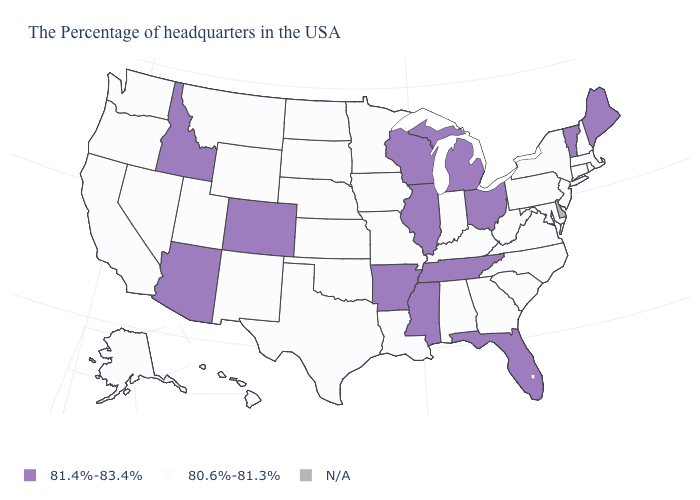What is the value of Arkansas?
Short answer required. 81.4%-83.4%. What is the value of Iowa?
Quick response, please. 80.6%-81.3%. What is the value of North Dakota?
Quick response, please. 80.6%-81.3%. Does Ohio have the highest value in the MidWest?
Be succinct. Yes. What is the value of Delaware?
Keep it brief. N/A. Does Vermont have the highest value in the Northeast?
Keep it brief. Yes. What is the value of Arkansas?
Short answer required. 81.4%-83.4%. Among the states that border Montana , does Idaho have the highest value?
Write a very short answer. Yes. Among the states that border North Carolina , does South Carolina have the highest value?
Quick response, please. No. What is the value of Kentucky?
Give a very brief answer. 80.6%-81.3%. What is the value of Vermont?
Write a very short answer. 81.4%-83.4%. Does the map have missing data?
Be succinct. Yes. What is the value of Florida?
Write a very short answer. 81.4%-83.4%. What is the value of Florida?
Answer briefly. 81.4%-83.4%. Name the states that have a value in the range 80.6%-81.3%?
Concise answer only. Massachusetts, Rhode Island, New Hampshire, Connecticut, New York, New Jersey, Maryland, Pennsylvania, Virginia, North Carolina, South Carolina, West Virginia, Georgia, Kentucky, Indiana, Alabama, Louisiana, Missouri, Minnesota, Iowa, Kansas, Nebraska, Oklahoma, Texas, South Dakota, North Dakota, Wyoming, New Mexico, Utah, Montana, Nevada, California, Washington, Oregon, Alaska, Hawaii. 